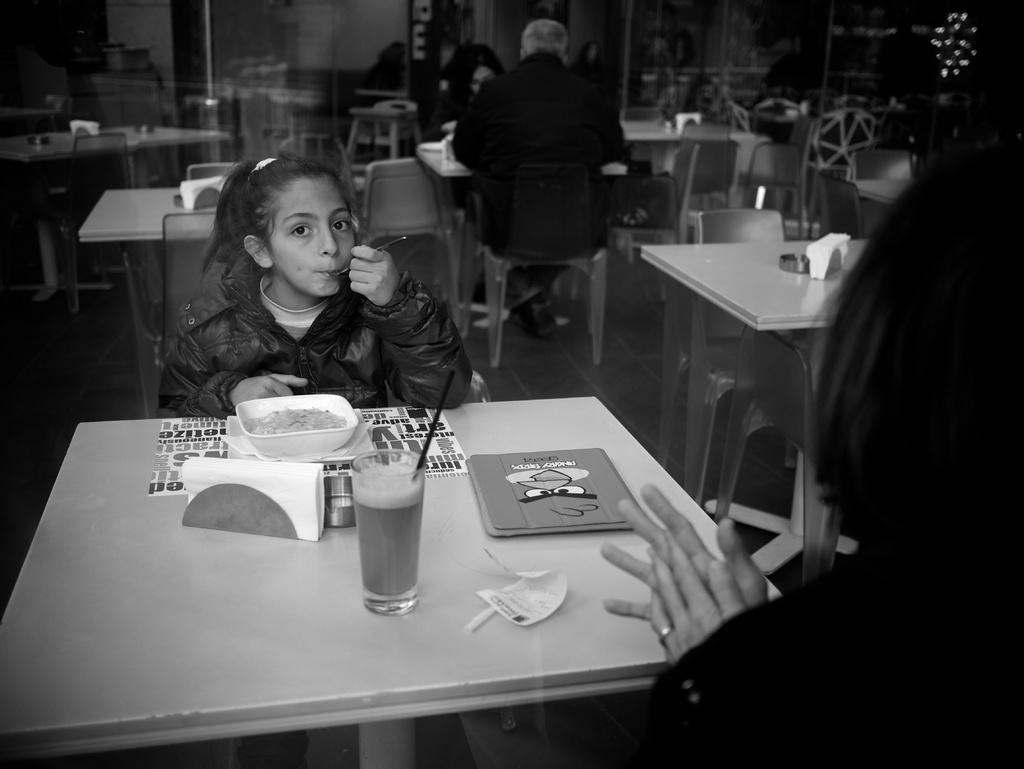What are the people in the image doing? The people in the image are sitting on chairs. How many chairs are visible in the image? There are multiple chairs in the image. What other furniture can be seen in the image? There are tables in the image. What is on one of the tables? There is a glass, food on a plate, and napkins on one of the tables. What verse is the sister reciting in the image? There is no sister or verse present in the image. How is the glue being used in the image? There is no glue present in the image. 